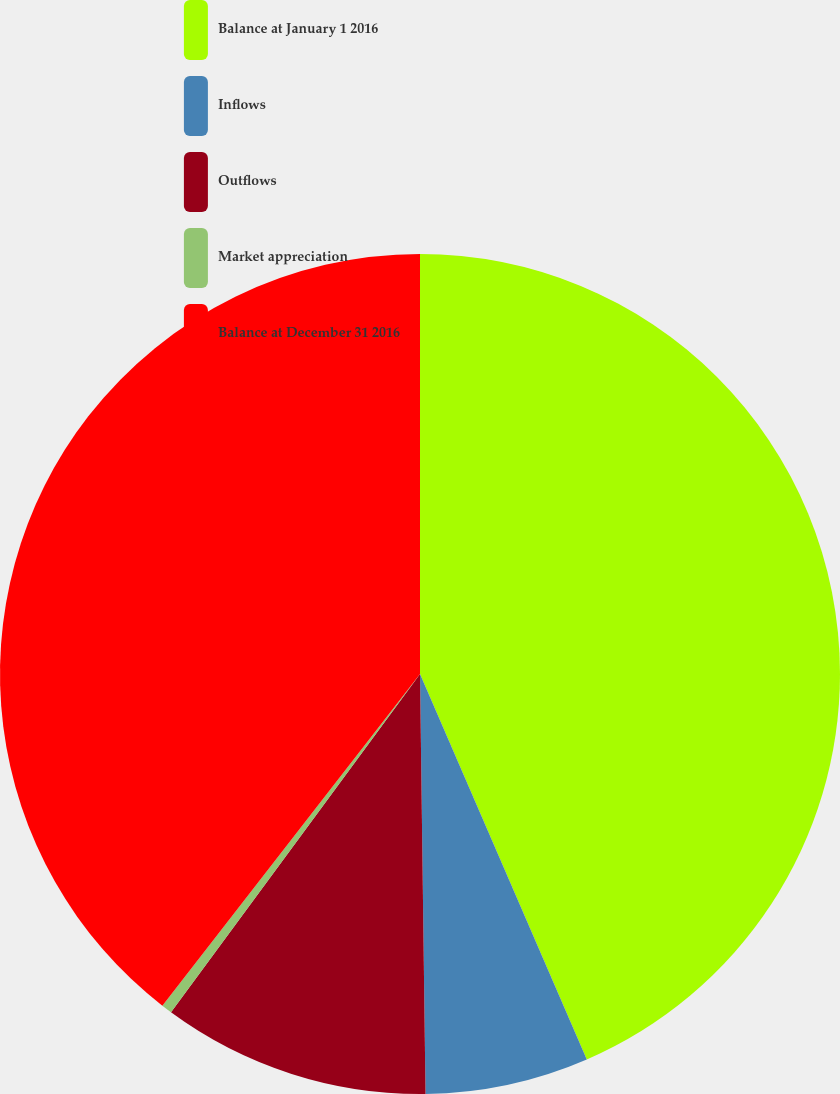Convert chart to OTSL. <chart><loc_0><loc_0><loc_500><loc_500><pie_chart><fcel>Balance at January 1 2016<fcel>Inflows<fcel>Outflows<fcel>Market appreciation<fcel>Balance at December 31 2016<nl><fcel>43.5%<fcel>6.29%<fcel>10.31%<fcel>0.41%<fcel>39.49%<nl></chart> 